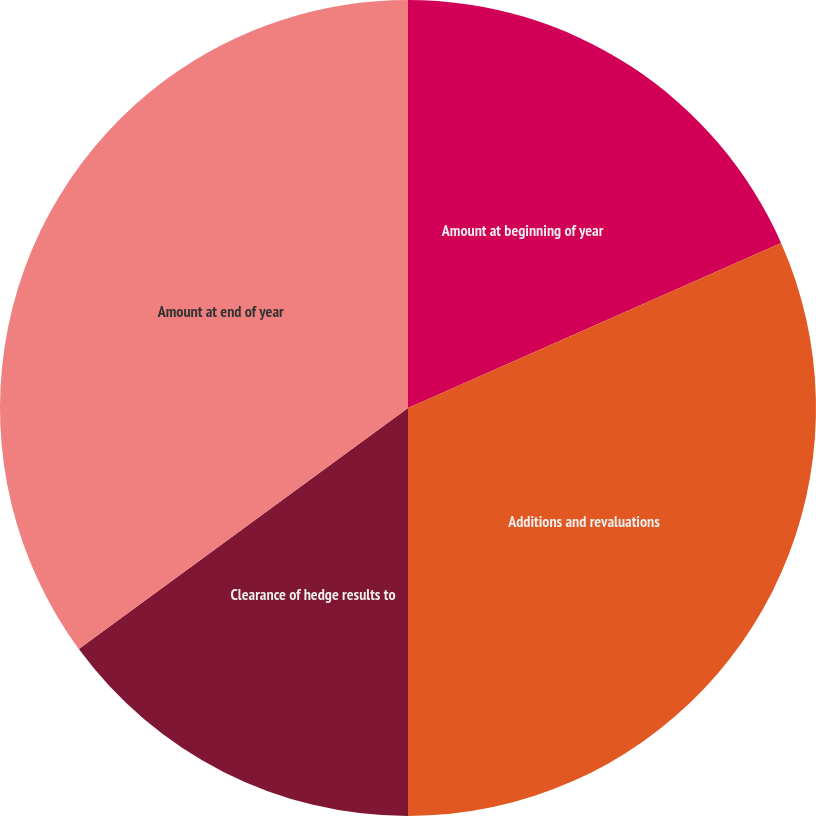Convert chart to OTSL. <chart><loc_0><loc_0><loc_500><loc_500><pie_chart><fcel>Amount at beginning of year<fcel>Additions and revaluations<fcel>Clearance of hedge results to<fcel>Amount at end of year<nl><fcel>18.37%<fcel>31.63%<fcel>14.94%<fcel>35.06%<nl></chart> 